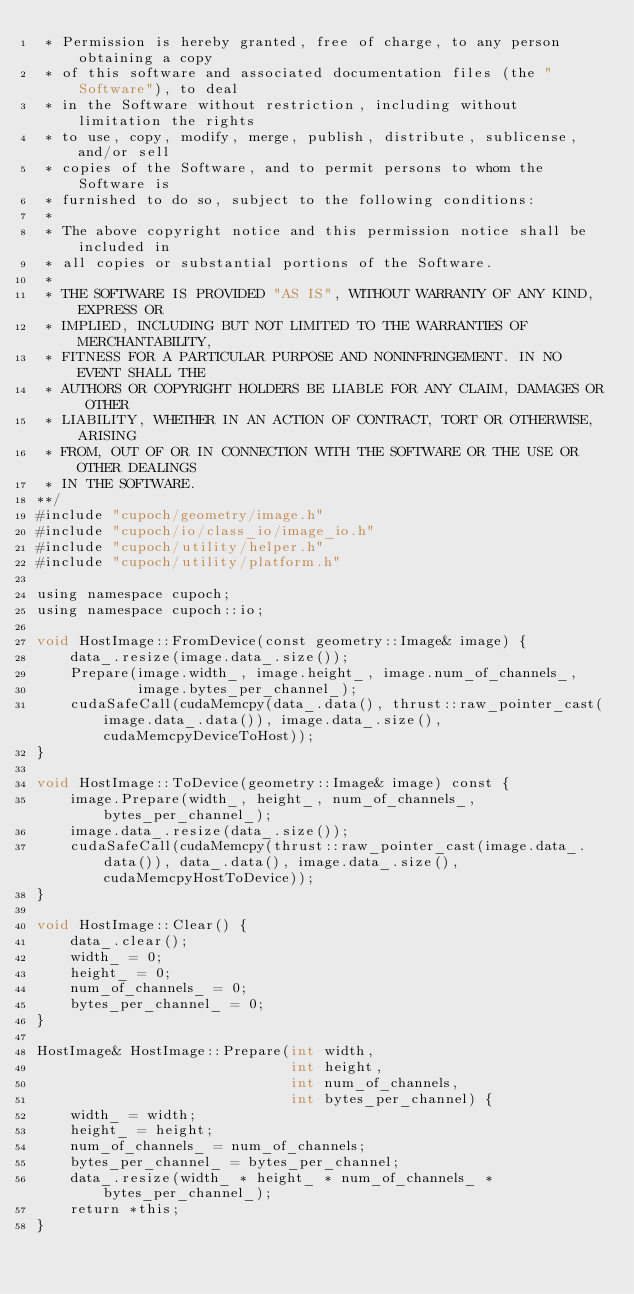<code> <loc_0><loc_0><loc_500><loc_500><_Cuda_> * Permission is hereby granted, free of charge, to any person obtaining a copy
 * of this software and associated documentation files (the "Software"), to deal
 * in the Software without restriction, including without limitation the rights
 * to use, copy, modify, merge, publish, distribute, sublicense, and/or sell
 * copies of the Software, and to permit persons to whom the Software is
 * furnished to do so, subject to the following conditions:
 * 
 * The above copyright notice and this permission notice shall be included in
 * all copies or substantial portions of the Software.
 * 
 * THE SOFTWARE IS PROVIDED "AS IS", WITHOUT WARRANTY OF ANY KIND, EXPRESS OR
 * IMPLIED, INCLUDING BUT NOT LIMITED TO THE WARRANTIES OF MERCHANTABILITY,
 * FITNESS FOR A PARTICULAR PURPOSE AND NONINFRINGEMENT. IN NO EVENT SHALL THE
 * AUTHORS OR COPYRIGHT HOLDERS BE LIABLE FOR ANY CLAIM, DAMAGES OR OTHER
 * LIABILITY, WHETHER IN AN ACTION OF CONTRACT, TORT OR OTHERWISE, ARISING
 * FROM, OUT OF OR IN CONNECTION WITH THE SOFTWARE OR THE USE OR OTHER DEALINGS
 * IN THE SOFTWARE.
**/
#include "cupoch/geometry/image.h"
#include "cupoch/io/class_io/image_io.h"
#include "cupoch/utility/helper.h"
#include "cupoch/utility/platform.h"

using namespace cupoch;
using namespace cupoch::io;

void HostImage::FromDevice(const geometry::Image& image) {
    data_.resize(image.data_.size());
    Prepare(image.width_, image.height_, image.num_of_channels_,
            image.bytes_per_channel_);
    cudaSafeCall(cudaMemcpy(data_.data(), thrust::raw_pointer_cast(image.data_.data()), image.data_.size(), cudaMemcpyDeviceToHost));
}

void HostImage::ToDevice(geometry::Image& image) const {
    image.Prepare(width_, height_, num_of_channels_, bytes_per_channel_);
    image.data_.resize(data_.size());
    cudaSafeCall(cudaMemcpy(thrust::raw_pointer_cast(image.data_.data()), data_.data(), image.data_.size(), cudaMemcpyHostToDevice));
}

void HostImage::Clear() {
    data_.clear();
    width_ = 0;
    height_ = 0;
    num_of_channels_ = 0;
    bytes_per_channel_ = 0;
}

HostImage& HostImage::Prepare(int width,
                              int height,
                              int num_of_channels,
                              int bytes_per_channel) {
    width_ = width;
    height_ = height;
    num_of_channels_ = num_of_channels;
    bytes_per_channel_ = bytes_per_channel;
    data_.resize(width_ * height_ * num_of_channels_ * bytes_per_channel_);
    return *this;
}</code> 